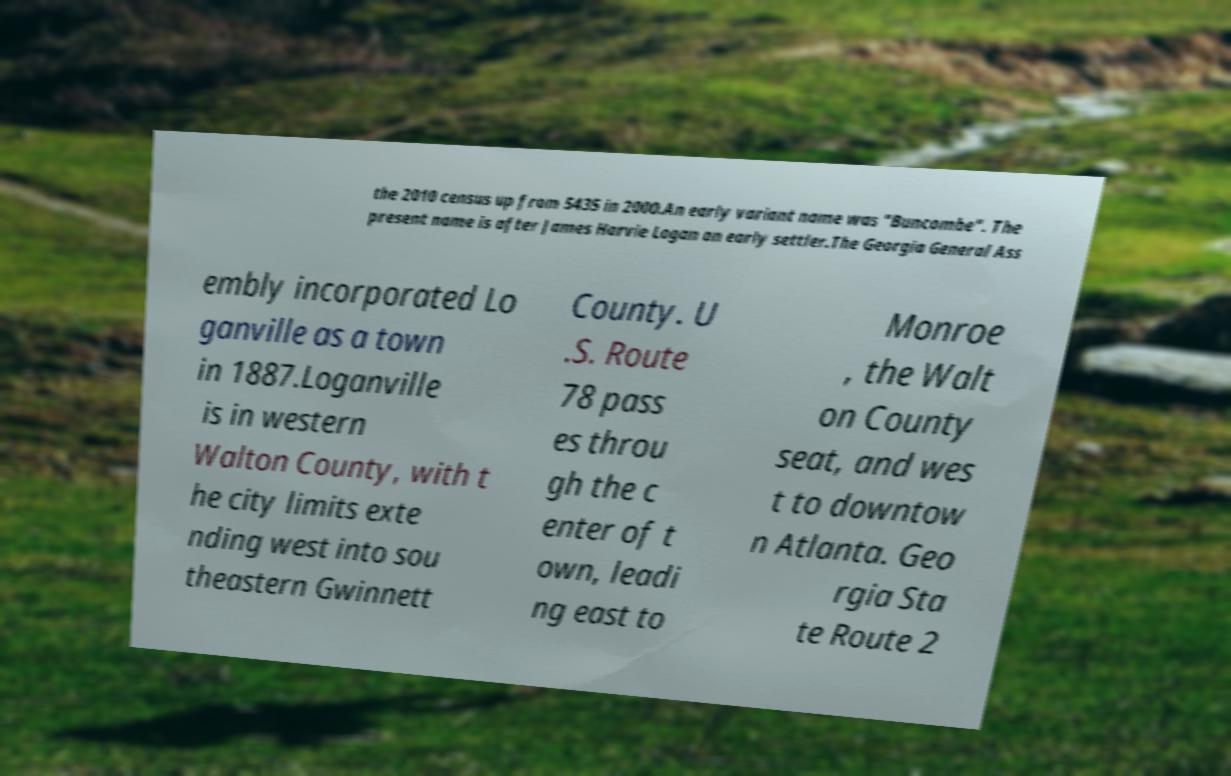What messages or text are displayed in this image? I need them in a readable, typed format. the 2010 census up from 5435 in 2000.An early variant name was "Buncombe". The present name is after James Harvie Logan an early settler.The Georgia General Ass embly incorporated Lo ganville as a town in 1887.Loganville is in western Walton County, with t he city limits exte nding west into sou theastern Gwinnett County. U .S. Route 78 pass es throu gh the c enter of t own, leadi ng east to Monroe , the Walt on County seat, and wes t to downtow n Atlanta. Geo rgia Sta te Route 2 